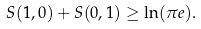Convert formula to latex. <formula><loc_0><loc_0><loc_500><loc_500>S ( 1 , 0 ) + S ( 0 , 1 ) \geq \ln ( \pi e ) .</formula> 